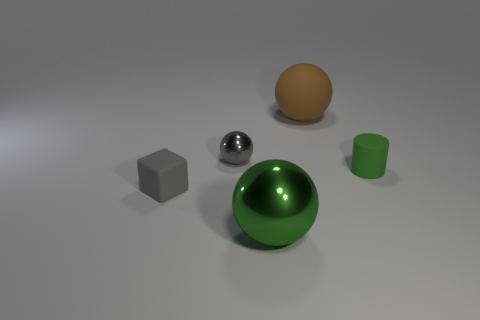Are there fewer large purple matte cubes than tiny cubes?
Provide a short and direct response. Yes. There is a small matte thing behind the small gray thing that is left of the small gray ball; are there any small gray metallic balls in front of it?
Offer a terse response. No. Is the shape of the gray object that is on the right side of the matte cube the same as  the small gray matte thing?
Provide a succinct answer. No. Is the number of tiny gray balls that are in front of the gray matte object greater than the number of large yellow matte spheres?
Ensure brevity in your answer.  No. There is a small matte object in front of the green rubber cylinder; is it the same color as the tiny metallic ball?
Your response must be concise. Yes. Is there anything else of the same color as the big matte sphere?
Your response must be concise. No. There is a small object to the left of the gray thing that is behind the matte object to the left of the big matte object; what color is it?
Your response must be concise. Gray. Does the gray sphere have the same size as the gray rubber thing?
Your answer should be very brief. Yes. How many red metallic cylinders have the same size as the gray shiny object?
Give a very brief answer. 0. There is a matte object that is the same color as the large shiny ball; what shape is it?
Provide a short and direct response. Cylinder. 